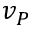Convert formula to latex. <formula><loc_0><loc_0><loc_500><loc_500>v _ { P }</formula> 